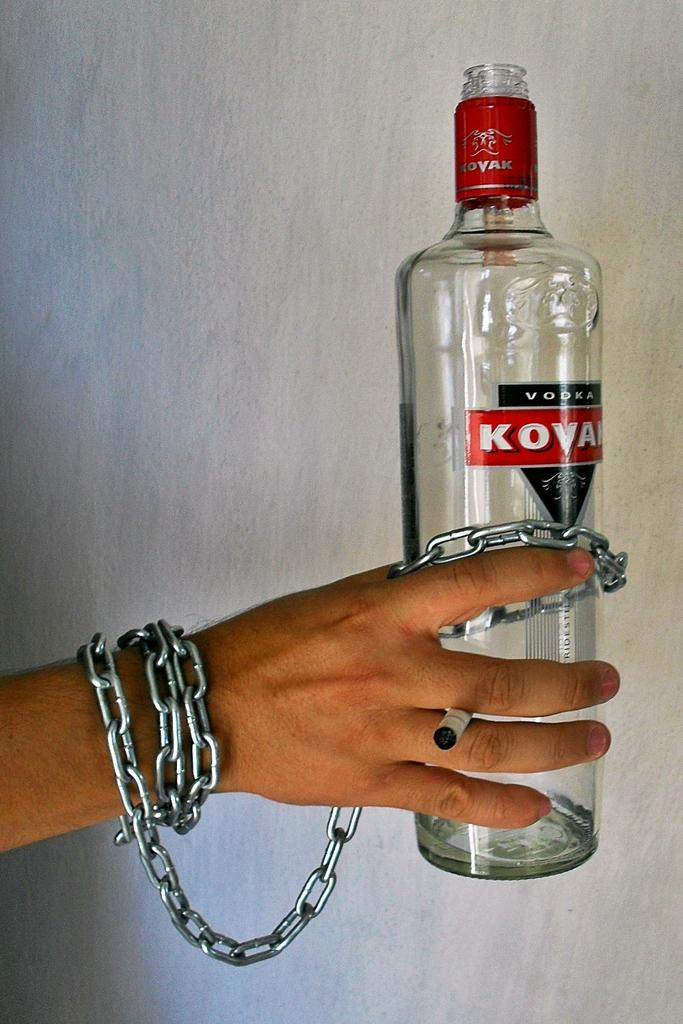Provide a one-sentence caption for the provided image. A person's right is chained to a bottle of Kovak vodka.. 